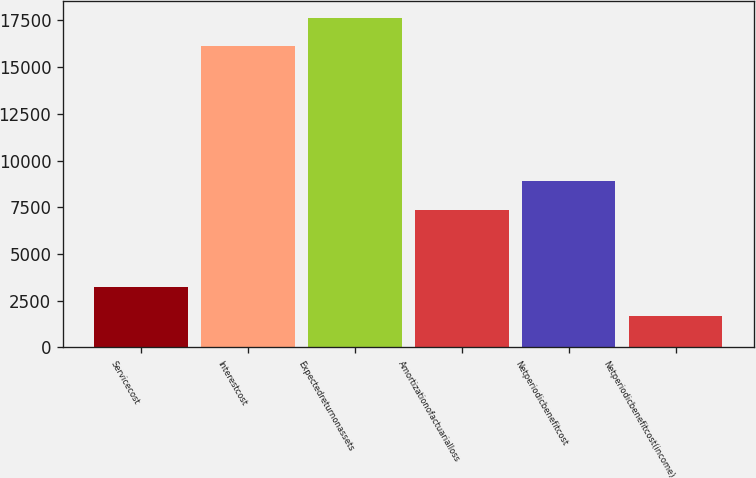<chart> <loc_0><loc_0><loc_500><loc_500><bar_chart><fcel>Servicecost<fcel>Interestcost<fcel>Expectedreturnonassets<fcel>Amortizationofactuarialloss<fcel>Netperiodicbenefitcost<fcel>Netperiodicbenefitcost(income)<nl><fcel>3237.6<fcel>16106<fcel>17636.6<fcel>7361<fcel>8891.6<fcel>1707<nl></chart> 